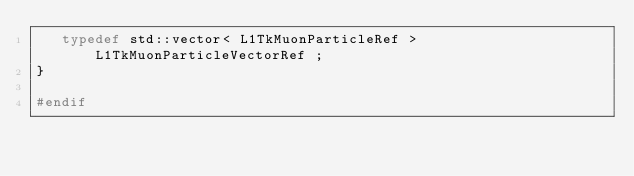<code> <loc_0><loc_0><loc_500><loc_500><_C_>   typedef std::vector< L1TkMuonParticleRef > L1TkMuonParticleVectorRef ;
}

#endif


</code> 